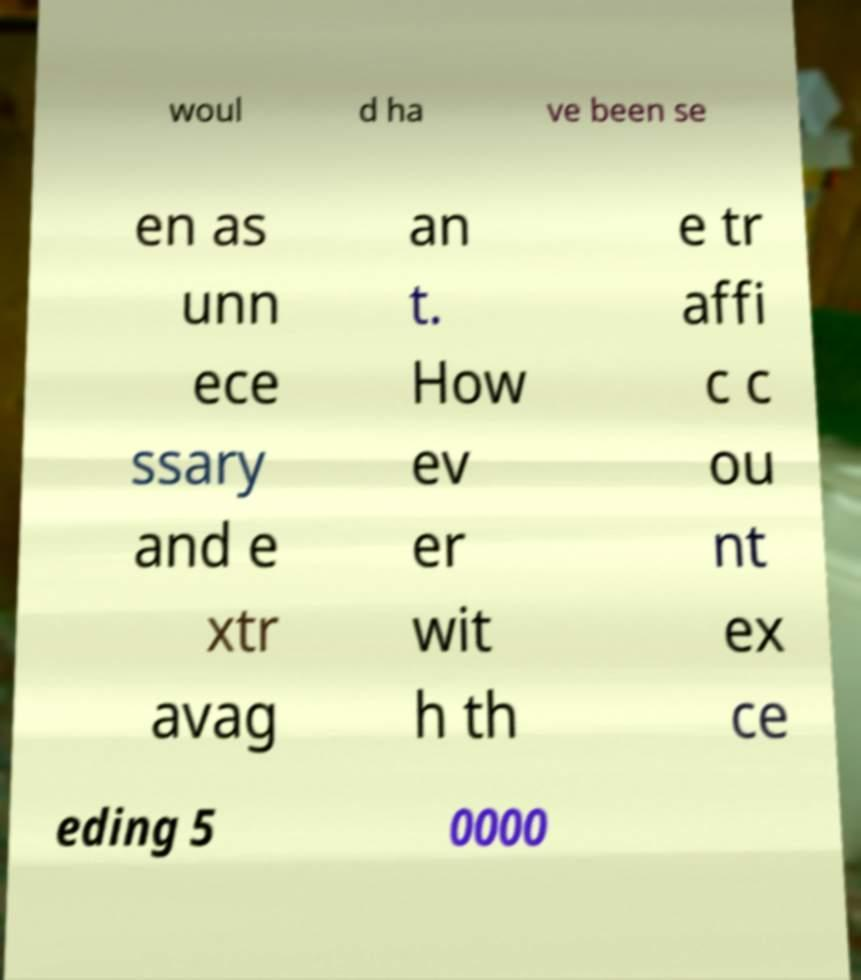Please identify and transcribe the text found in this image. woul d ha ve been se en as unn ece ssary and e xtr avag an t. How ev er wit h th e tr affi c c ou nt ex ce eding 5 0000 